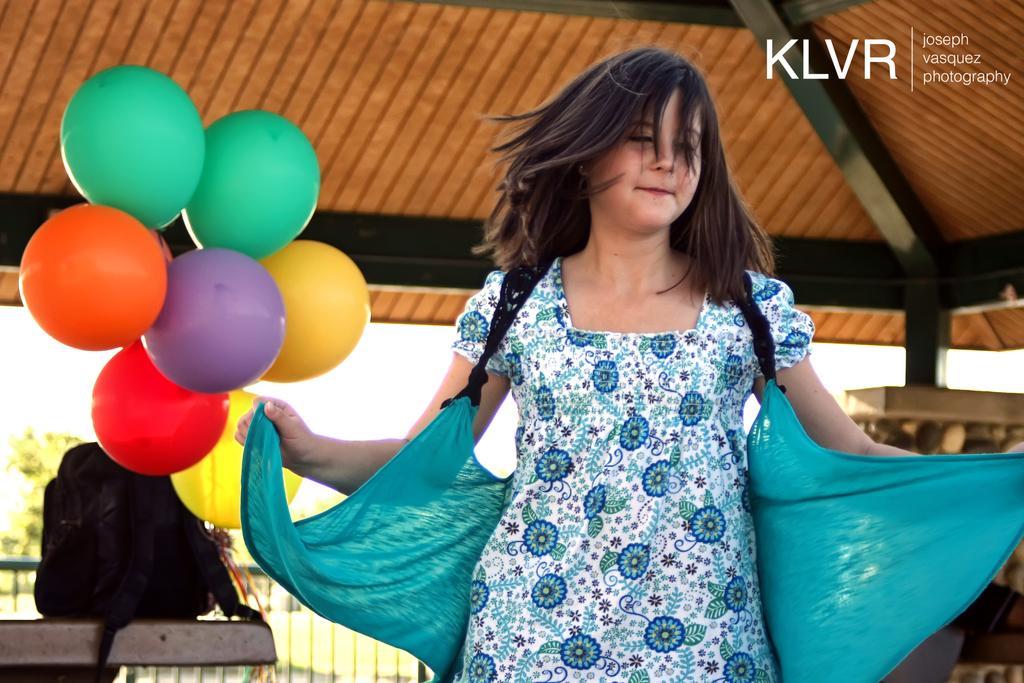Can you describe this image briefly? In this picture there is a girl and we can see balloons, bag on the platform, railing and shed. In the background of the image it is blurry and we can see the sky. In the top right side of the image we can see text. 